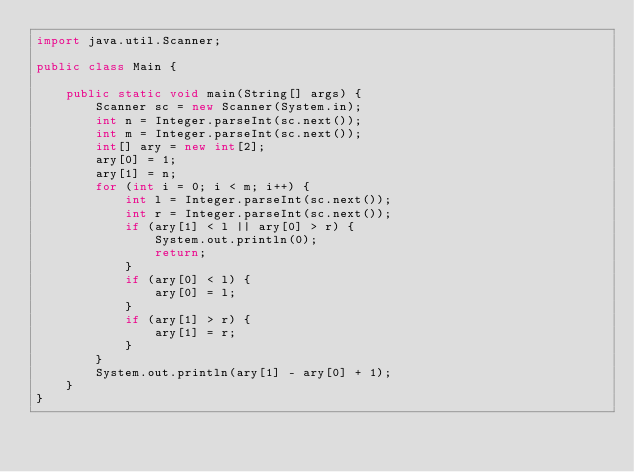<code> <loc_0><loc_0><loc_500><loc_500><_Java_>import java.util.Scanner;

public class Main {

    public static void main(String[] args) {
        Scanner sc = new Scanner(System.in);
        int n = Integer.parseInt(sc.next());
        int m = Integer.parseInt(sc.next());
        int[] ary = new int[2];
        ary[0] = 1;
        ary[1] = n;
        for (int i = 0; i < m; i++) {
            int l = Integer.parseInt(sc.next());
            int r = Integer.parseInt(sc.next());
            if (ary[1] < l || ary[0] > r) {
                System.out.println(0);
                return;
            }
            if (ary[0] < l) {
                ary[0] = l;
            }
            if (ary[1] > r) {
                ary[1] = r;
            }
        }
        System.out.println(ary[1] - ary[0] + 1);
    }
}</code> 